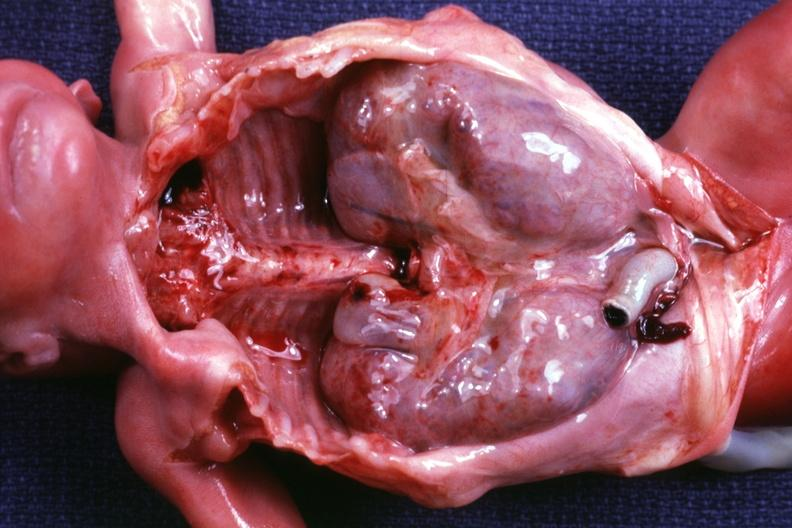does this image show kidneys in situ with other organs removed dramatic demonstration of size of kidneys?
Answer the question using a single word or phrase. Yes 